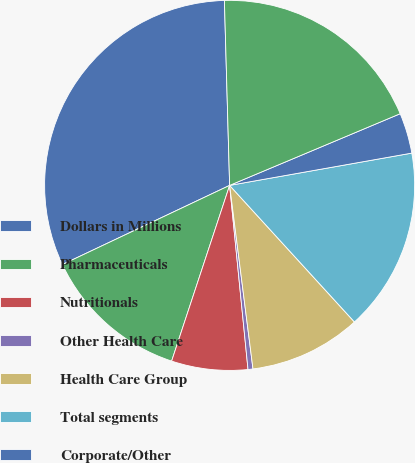Convert chart to OTSL. <chart><loc_0><loc_0><loc_500><loc_500><pie_chart><fcel>Dollars in Millions<fcel>Pharmaceuticals<fcel>Nutritionals<fcel>Other Health Care<fcel>Health Care Group<fcel>Total segments<fcel>Corporate/Other<fcel>Total<nl><fcel>31.59%<fcel>12.89%<fcel>6.66%<fcel>0.43%<fcel>9.77%<fcel>16.01%<fcel>3.54%<fcel>19.12%<nl></chart> 